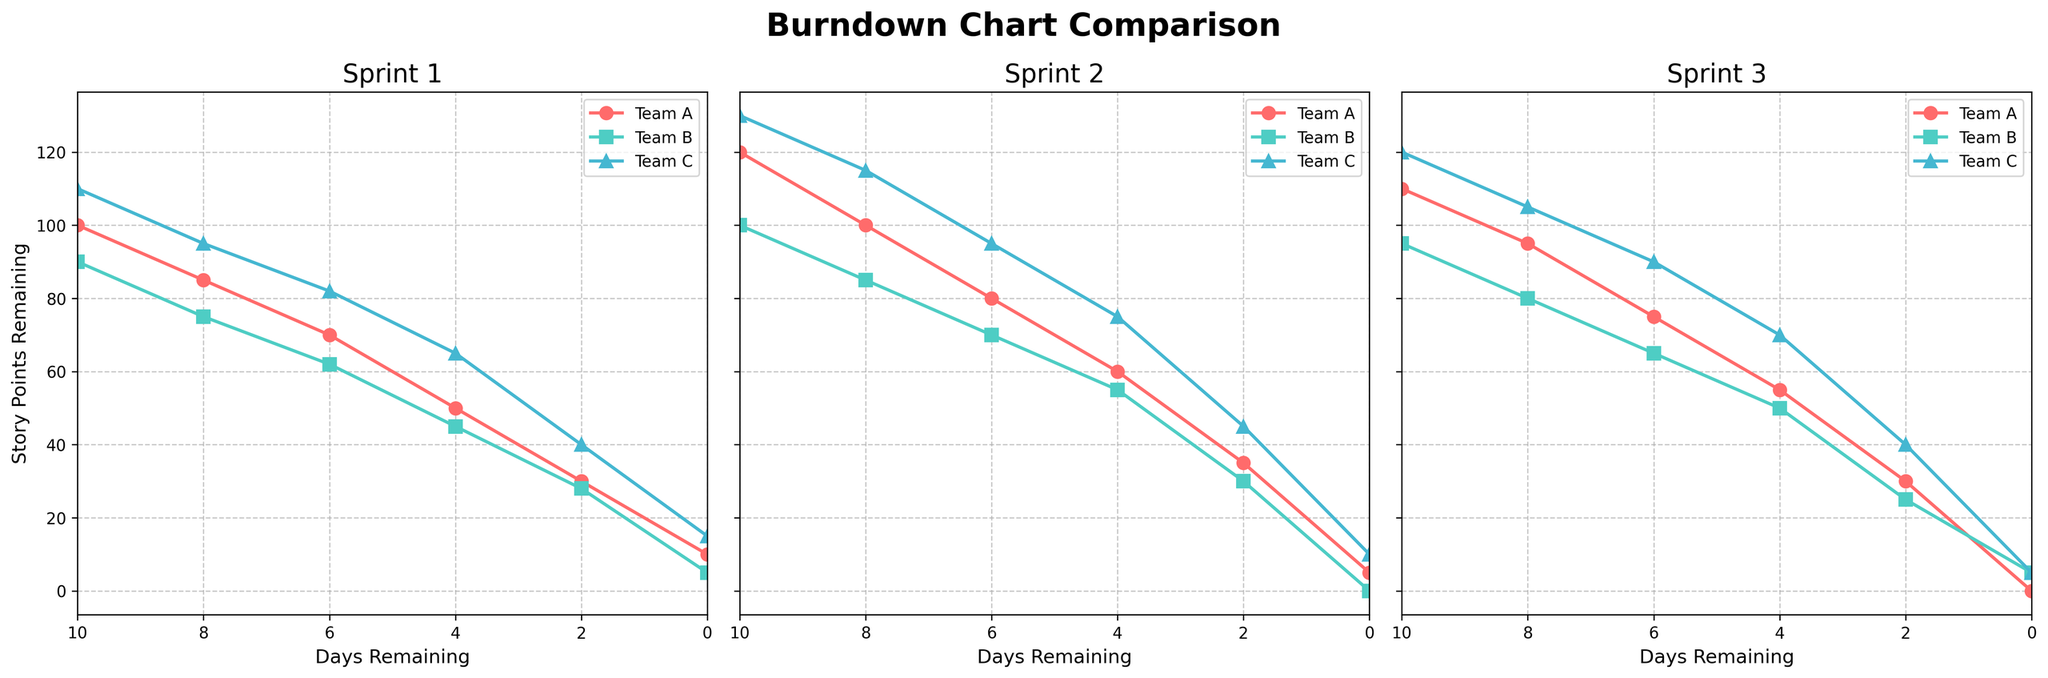What's the title of the figure? The title is usually found at the top of the figure. For this plot, it is clearly stated as "Burndown Chart Comparison".
Answer: Burndown Chart Comparison How many subplots are there in the figure? The subplots correspond to different sprints. There are three subplots, one for each sprint (1, 2, and 3).
Answer: 3 What is the trend for Team B in Sprint 1? To determine the trend, look at the line representing Team B's story points in Sprint 1. The points decrease from 90 to 5 over the days remaining.
Answer: Decreasing Which team has the lowest story points remaining at the end of Sprint 2? By checking the final data points (Days Remaining: 0) in the Sprint 2 subplot, we see that Team A has 5 points, Team B has 0 points, and Team C has 10 points. The lowest is Team B.
Answer: Team B How do the story points of Team A change from the start to the end of Sprint 3? Look at the line for Team A in Sprint 3. At the start (Days Remaining: 10), it is 110, and at the end (Days Remaining: 0), it is 0.
Answer: Decrease from 110 to 0 Compare the story points of Team A and Team C at the midway point of Sprint 1 (Days Remaining: 4). Check the values of Team A and Team C at Days Remaining: 4 in Sprint 1. Team A has 50 points and Team C has 65.
Answer: Team A: 50, Team C: 65 Which sprint shows the steepest decline in story points for Team C? To find the steepest decline, observe the slopes of Team C's lines across the sprints. The steepest slope appears in Sprint 3 where the points drop from 120 to 5 (Days Remaining: 0).
Answer: Sprint 3 How many times does the figure include "Days Remaining" as an x-axis label? Each subplot uses "Days Remaining" as the x-axis label. There are three subplots.
Answer: 3 What is the sum of the remaining story points for all teams at the start of Sprint 2? At Days Remaining: 10 in Sprint 2, sum the story points for Team A (120), Team B (100), and Team C (130). 120 + 100 + 130 = 350.
Answer: 350 